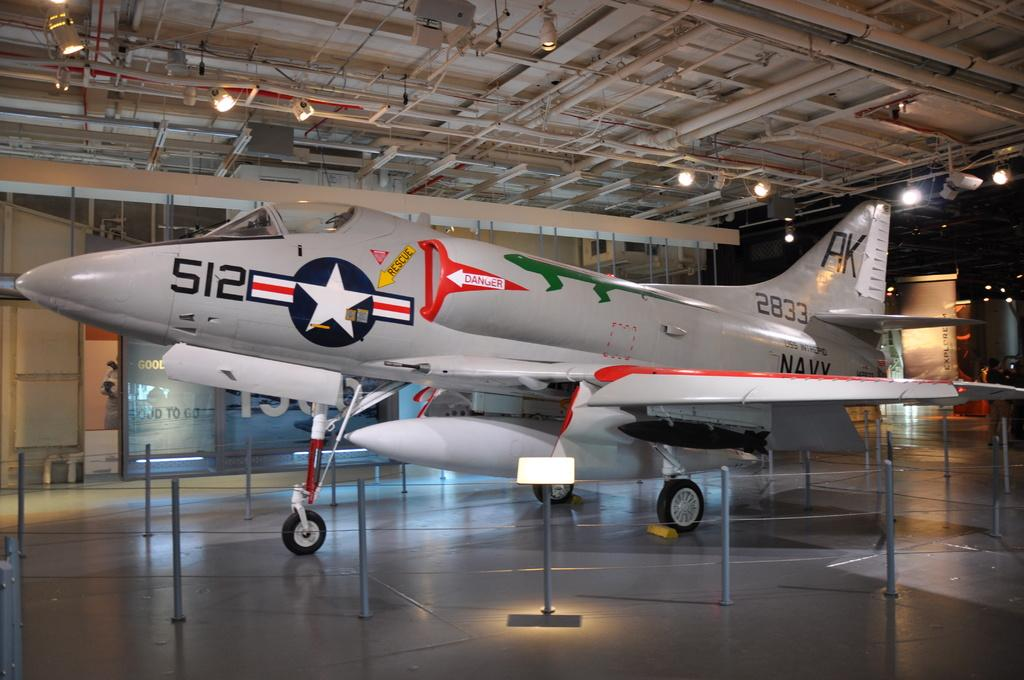<image>
Create a compact narrative representing the image presented. A Navy airplane with the numbers 512 on the front and the letters AK on the back . 